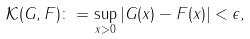<formula> <loc_0><loc_0><loc_500><loc_500>\mathcal { K } ( G , F ) \colon = \sup _ { x > 0 } | G ( x ) - F ( x ) | < \epsilon ,</formula> 